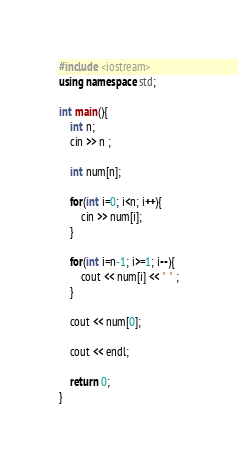Convert code to text. <code><loc_0><loc_0><loc_500><loc_500><_C++_>#include <iostream>
using namespace std;

int main(){
	int n;
	cin >> n ;

	int num[n];

	for(int i=0; i<n; i++){
		cin >> num[i];
	}

	for(int i=n-1; i>=1; i--){
		cout << num[i] << " " ;
	}
	
	cout << num[0];

	cout << endl;

	return 0;
}</code> 